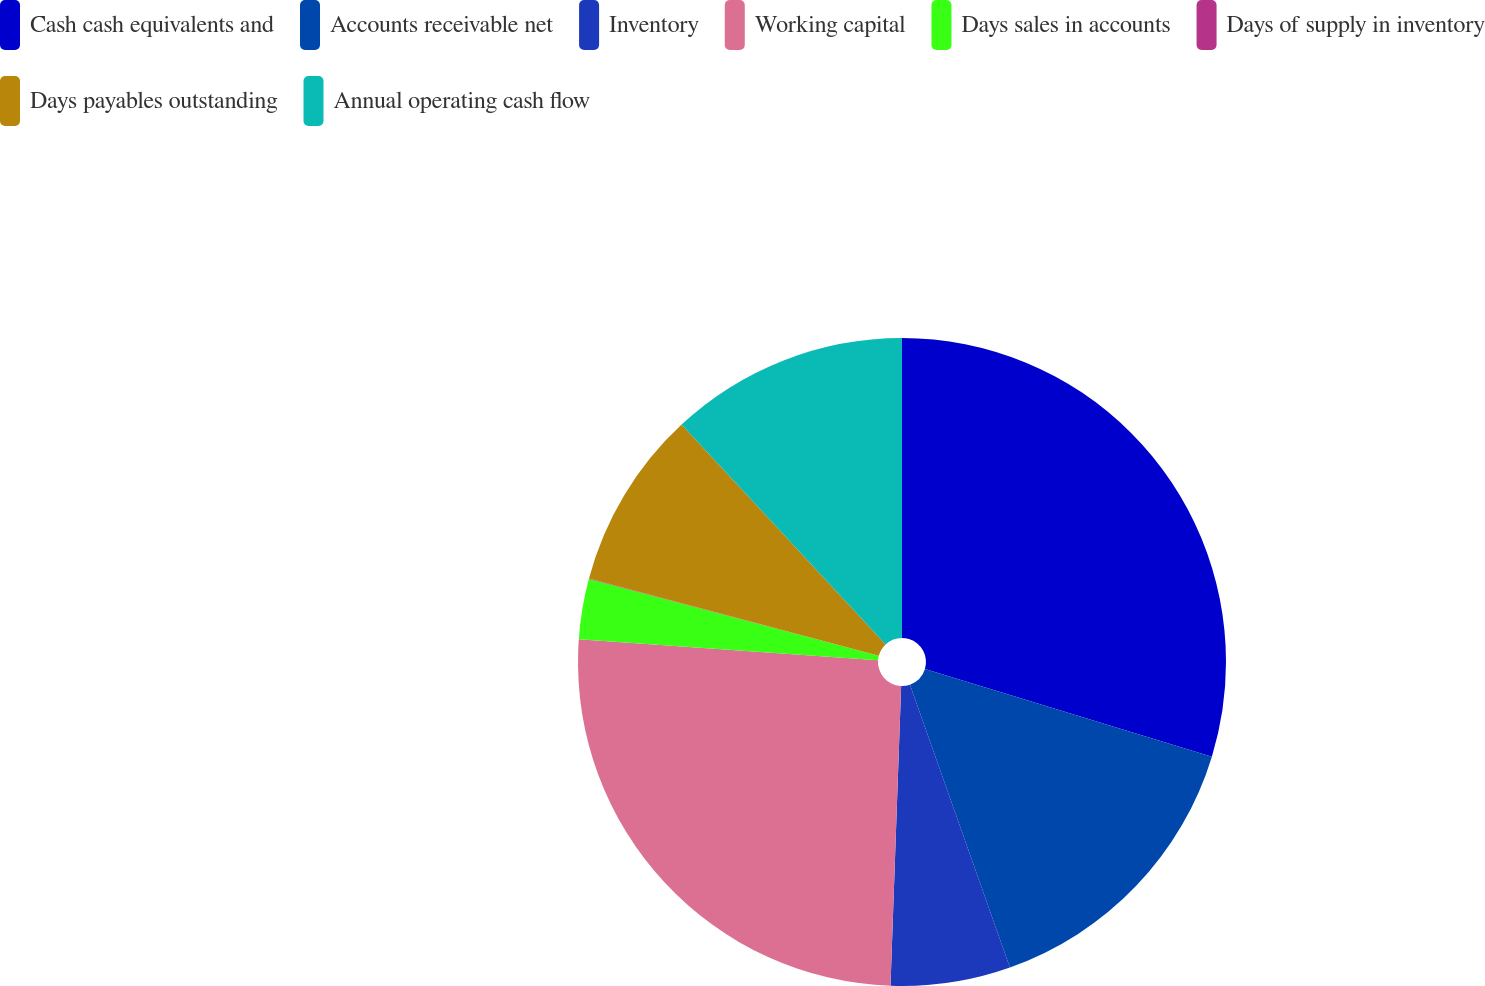Convert chart. <chart><loc_0><loc_0><loc_500><loc_500><pie_chart><fcel>Cash cash equivalents and<fcel>Accounts receivable net<fcel>Inventory<fcel>Working capital<fcel>Days sales in accounts<fcel>Days of supply in inventory<fcel>Days payables outstanding<fcel>Annual operating cash flow<nl><fcel>29.72%<fcel>14.88%<fcel>5.97%<fcel>25.56%<fcel>3.0%<fcel>0.03%<fcel>8.94%<fcel>11.91%<nl></chart> 